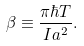<formula> <loc_0><loc_0><loc_500><loc_500>\beta \equiv \frac { \pi \hbar { T } } { I a ^ { 2 } } .</formula> 